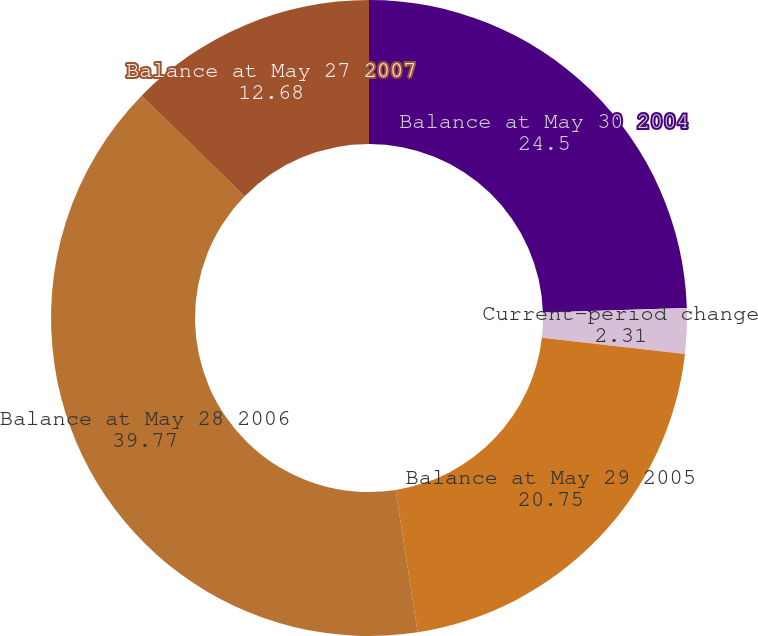Convert chart. <chart><loc_0><loc_0><loc_500><loc_500><pie_chart><fcel>Balance at May 30 2004<fcel>Current-period change<fcel>Balance at May 29 2005<fcel>Balance at May 28 2006<fcel>Balance at May 27 2007<nl><fcel>24.5%<fcel>2.31%<fcel>20.75%<fcel>39.77%<fcel>12.68%<nl></chart> 